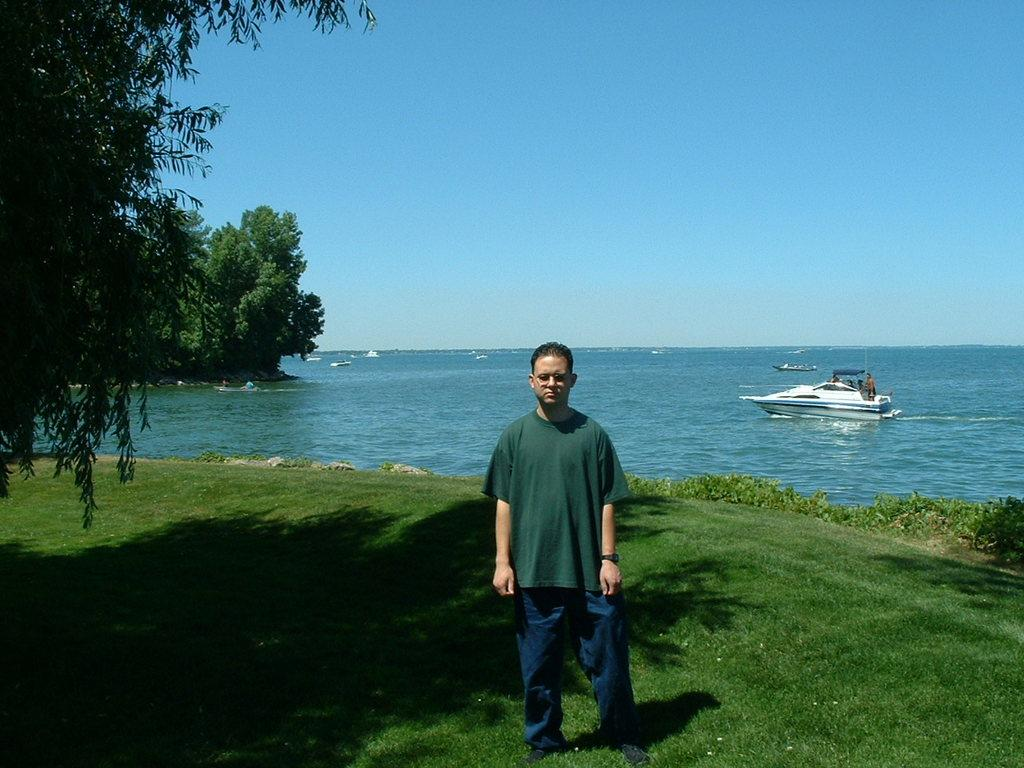What is the person in the image doing? The person is standing on the grass. What can be seen on the left side of the image? Trees are present on the left side of the image. What is visible in the background of the image? Boats are visible in the background, and they are on a river. What part of the natural environment is visible in the image? The sky is visible in the background. What type of kettle is being used to cook dinner in the image? There is no kettle or dinner present in the image; it features a person standing on the grass, trees, boats on a river, and the sky. 